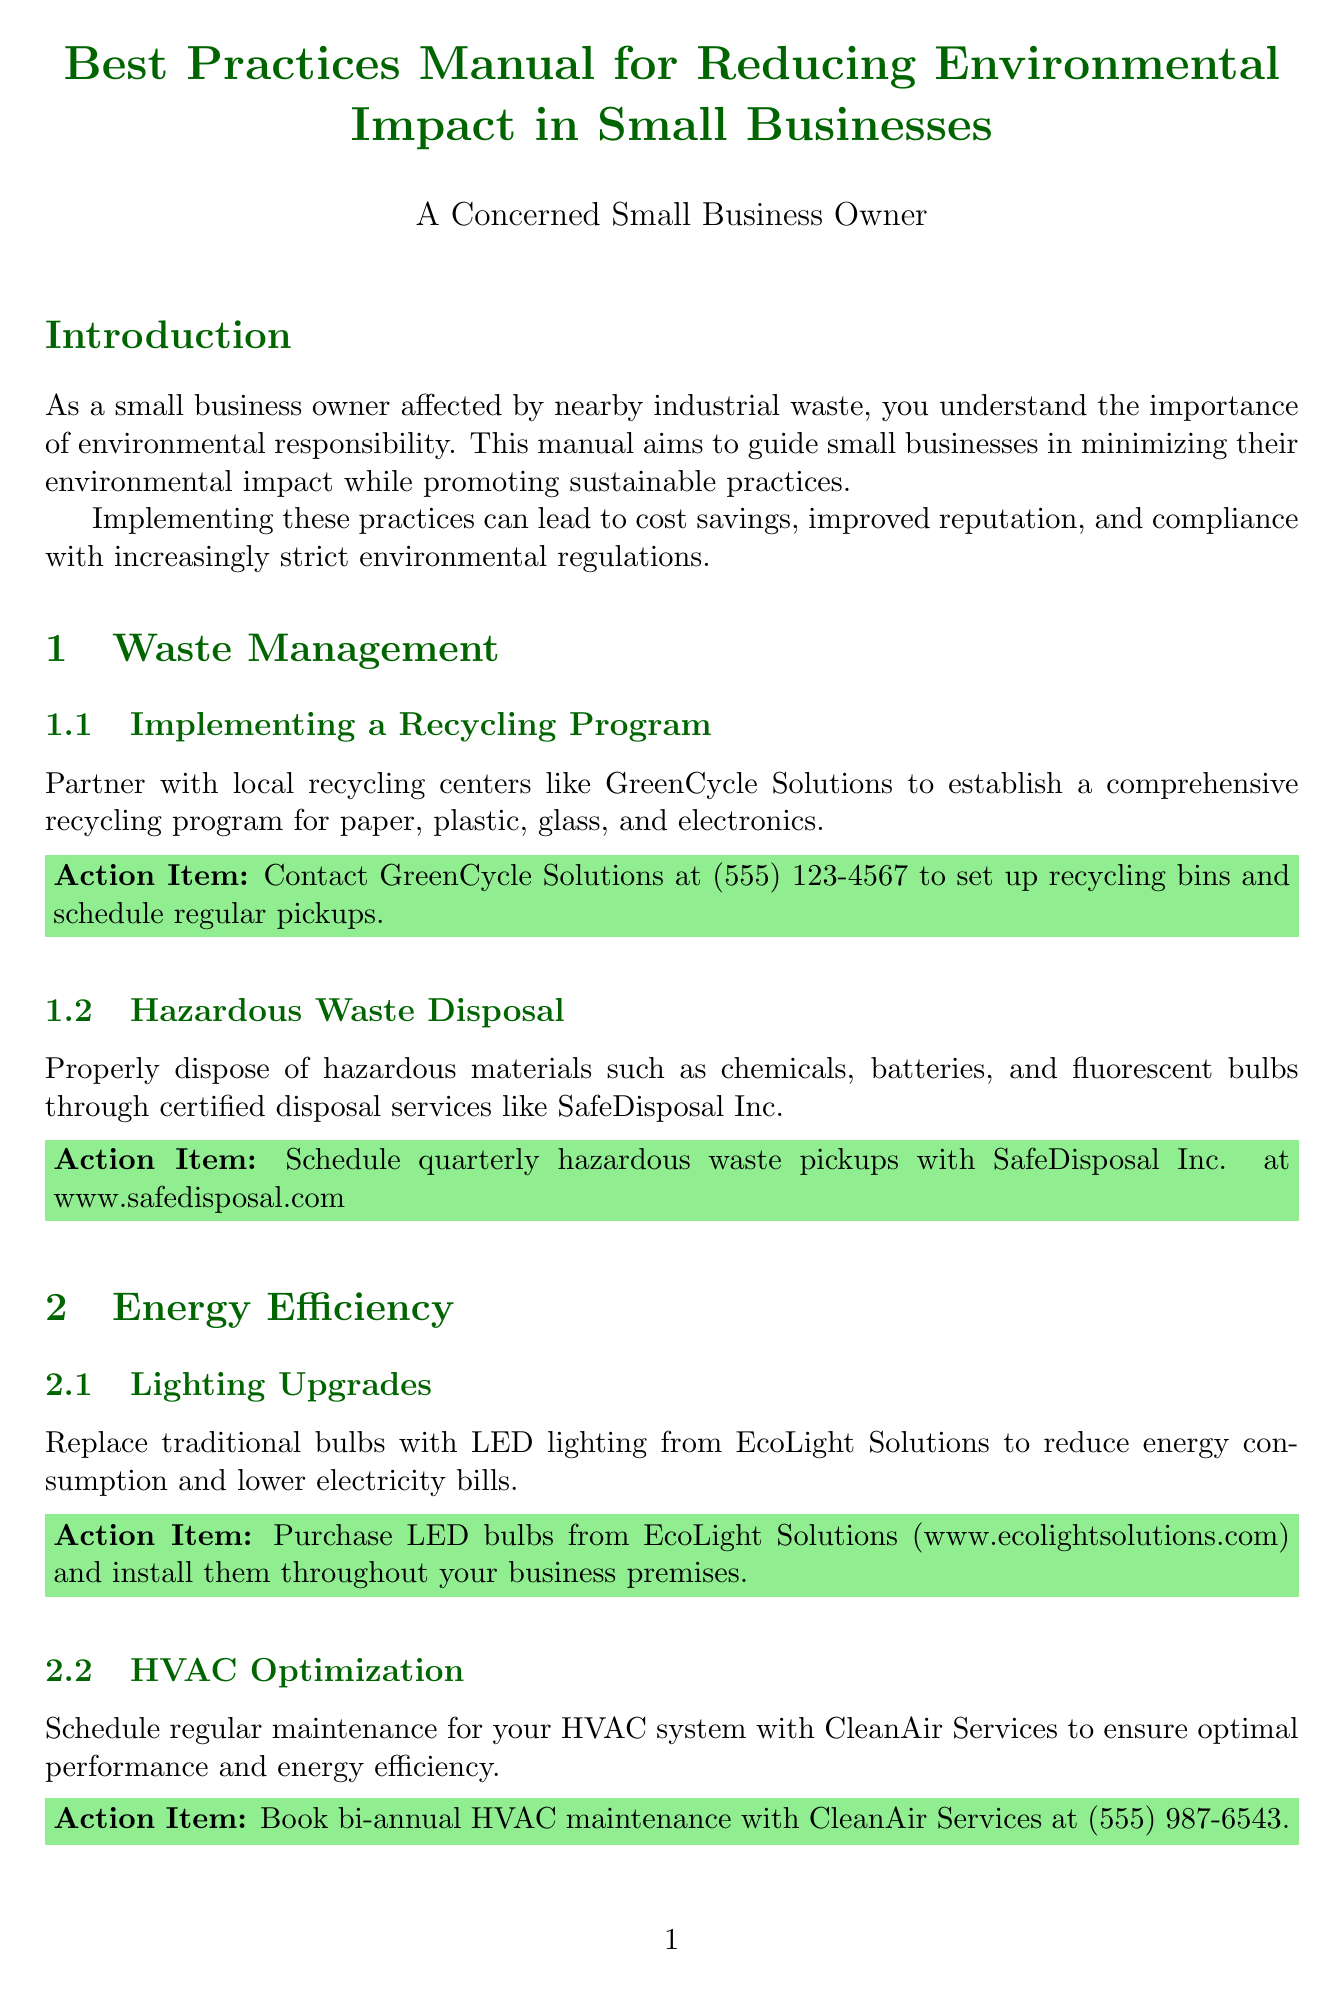What is the title of the manual? The title of the manual is stated at the beginning of the document.
Answer: Best Practices Manual for Reducing Environmental Impact in Small Businesses Who can you contact for establishing a recycling program? The document mentions a specific organization that helps set up recycling programs.
Answer: GreenCycle Solutions What should be implemented for hazardous waste disposal? The document provides guidance on the proper disposal of specific materials.
Answer: Certified disposal services What type of lighting is recommended to reduce energy consumption? The manual suggests a specific type of light bulb for energy efficiency.
Answer: LED lighting Which plumbing fixtures help in reducing water consumption? The document lists specific fixtures that can be installed to conserve water.
Answer: Low-flow faucets and toilets How often should HVAC maintenance be scheduled? The recommendation for scheduling maintenance is provided in the energy efficiency section of the manual.
Answer: Bi-annual What is one action item related to sustainable sourcing? The document includes an action item for sourcing that supports local economy and reduces emissions.
Answer: Discuss weekly deliveries of locally-sourced goods What type of training should be conducted for employee engagement? The document specifies the kind of training sessions recommended for employees.
Answer: Environmental awareness training sessions 